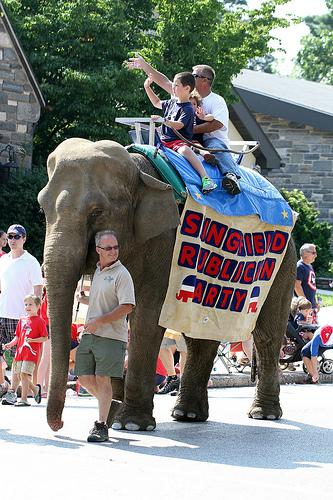Question: what kind of animal is this?
Choices:
A. Lion.
B. Zebra.
C. Tiger.
D. Elephant.
Answer with the letter. Answer: D Question: when was this photo taken?
Choices:
A. In the daytime.
B. In the evening.
C. In the morning.
D. At noon.
Answer with the letter. Answer: A Question: who is sitting on the animal?
Choices:
A. Some people.
B. A few kids.
C. The handler.
D. A tourist.
Answer with the letter. Answer: A Question: what is in the background?
Choices:
A. Mountains.
B. Some trees.
C. A beach.
D. A house.
Answer with the letter. Answer: B 